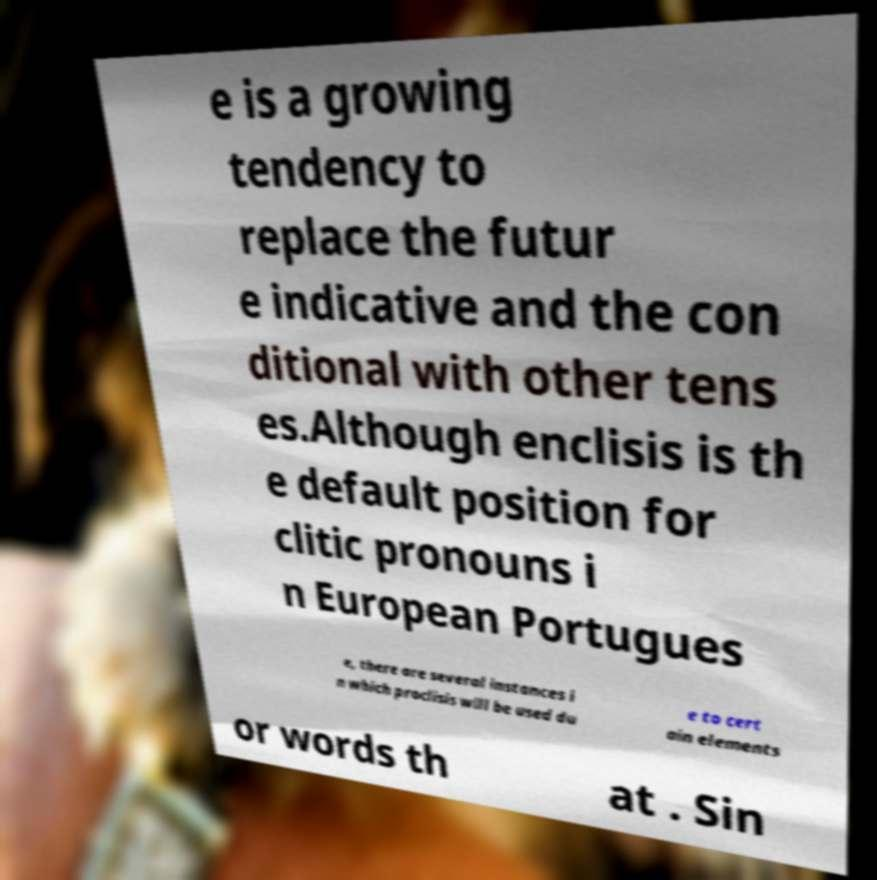Please read and relay the text visible in this image. What does it say? e is a growing tendency to replace the futur e indicative and the con ditional with other tens es.Although enclisis is th e default position for clitic pronouns i n European Portugues e, there are several instances i n which proclisis will be used du e to cert ain elements or words th at . Sin 